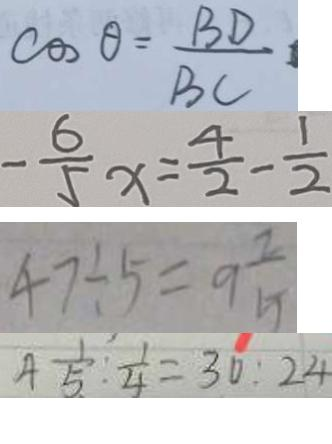Convert formula to latex. <formula><loc_0><loc_0><loc_500><loc_500>\cos \theta = \frac { B D } { B C } 
 - \frac { 6 } { 5 } x = \frac { 4 } { 2 } - \frac { 1 } { 2 } 
 4 7 \div 5 = 9 \frac { 2 } { 5 } 
 4 \frac { 1 } { 5 } : \frac { 1 } { 4 } = 3 0 : 2 4</formula> 